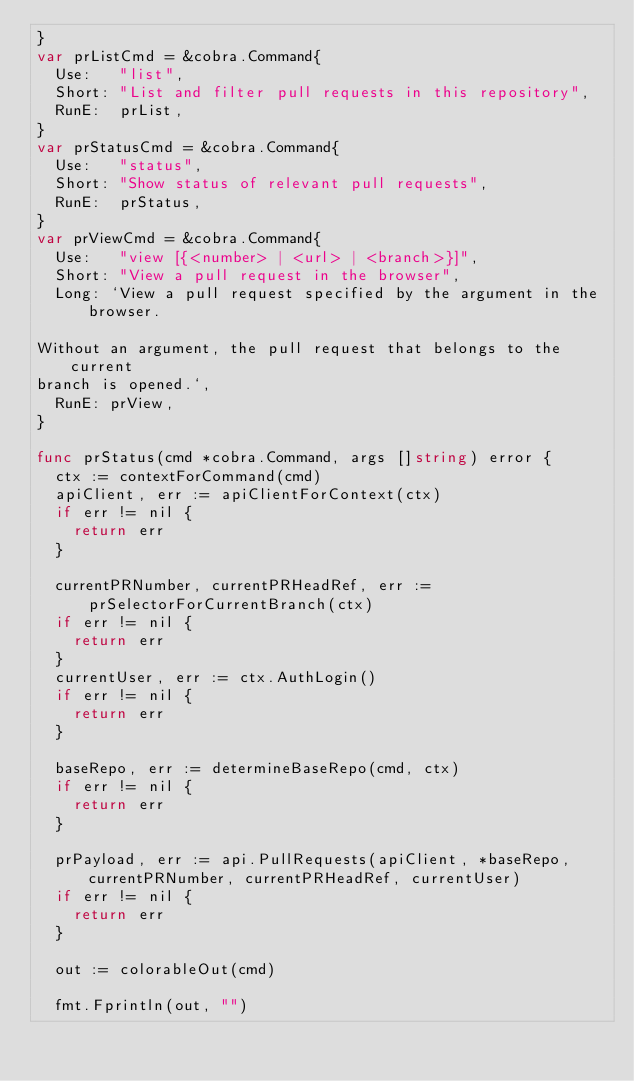Convert code to text. <code><loc_0><loc_0><loc_500><loc_500><_Go_>}
var prListCmd = &cobra.Command{
	Use:   "list",
	Short: "List and filter pull requests in this repository",
	RunE:  prList,
}
var prStatusCmd = &cobra.Command{
	Use:   "status",
	Short: "Show status of relevant pull requests",
	RunE:  prStatus,
}
var prViewCmd = &cobra.Command{
	Use:   "view [{<number> | <url> | <branch>}]",
	Short: "View a pull request in the browser",
	Long: `View a pull request specified by the argument in the browser.

Without an argument, the pull request that belongs to the current
branch is opened.`,
	RunE: prView,
}

func prStatus(cmd *cobra.Command, args []string) error {
	ctx := contextForCommand(cmd)
	apiClient, err := apiClientForContext(ctx)
	if err != nil {
		return err
	}

	currentPRNumber, currentPRHeadRef, err := prSelectorForCurrentBranch(ctx)
	if err != nil {
		return err
	}
	currentUser, err := ctx.AuthLogin()
	if err != nil {
		return err
	}

	baseRepo, err := determineBaseRepo(cmd, ctx)
	if err != nil {
		return err
	}

	prPayload, err := api.PullRequests(apiClient, *baseRepo, currentPRNumber, currentPRHeadRef, currentUser)
	if err != nil {
		return err
	}

	out := colorableOut(cmd)

	fmt.Fprintln(out, "")</code> 